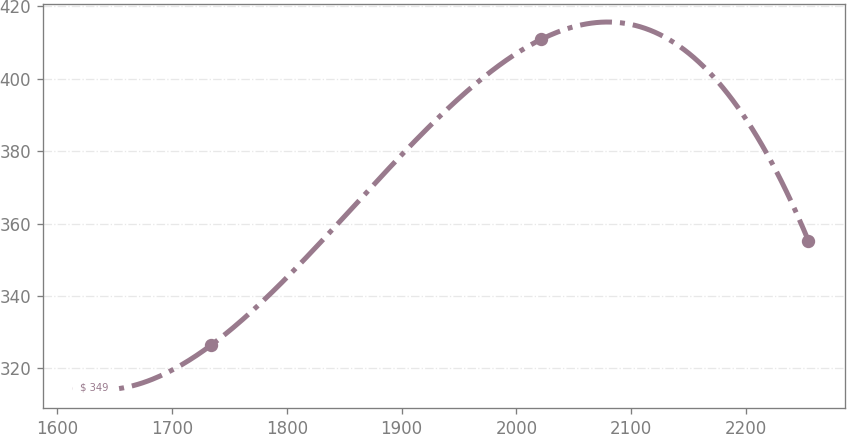Convert chart to OTSL. <chart><loc_0><loc_0><loc_500><loc_500><line_chart><ecel><fcel>$ 349<nl><fcel>1619.25<fcel>314.58<nl><fcel>1734.01<fcel>326.41<nl><fcel>2021.32<fcel>410.82<nl><fcel>2254.37<fcel>355.22<nl></chart> 